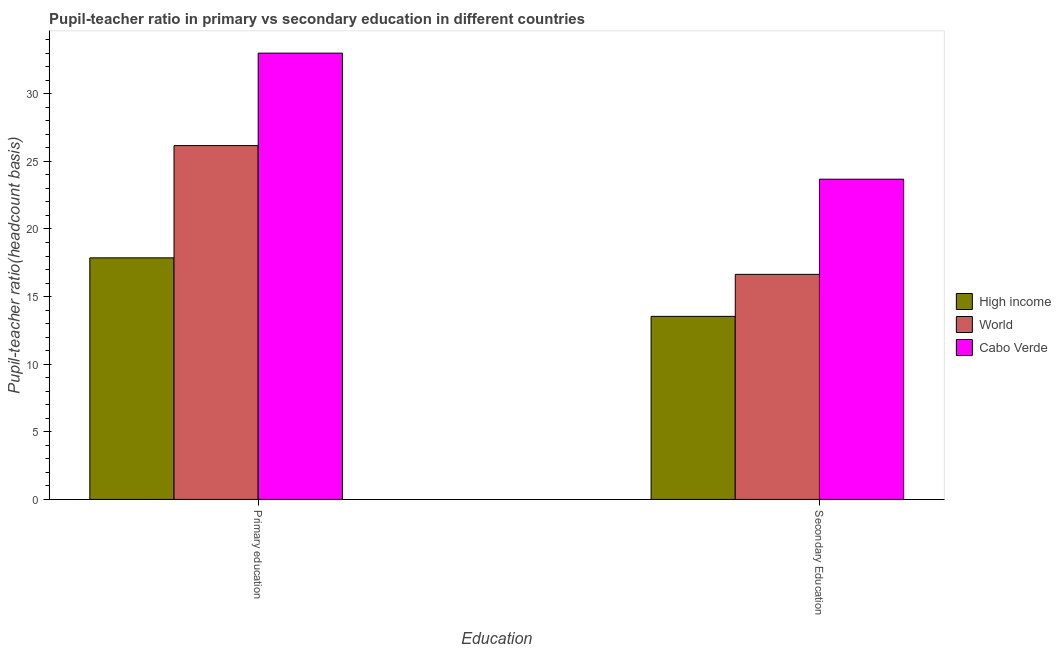How many different coloured bars are there?
Your response must be concise. 3. How many groups of bars are there?
Provide a succinct answer. 2. Are the number of bars per tick equal to the number of legend labels?
Keep it short and to the point. Yes. Are the number of bars on each tick of the X-axis equal?
Offer a very short reply. Yes. What is the label of the 1st group of bars from the left?
Keep it short and to the point. Primary education. What is the pupil-teacher ratio in primary education in High income?
Your answer should be compact. 17.86. Across all countries, what is the maximum pupil-teacher ratio in primary education?
Offer a very short reply. 33. Across all countries, what is the minimum pupil-teacher ratio in primary education?
Make the answer very short. 17.86. In which country was the pupil teacher ratio on secondary education maximum?
Your answer should be very brief. Cabo Verde. What is the total pupil-teacher ratio in primary education in the graph?
Make the answer very short. 77.03. What is the difference between the pupil-teacher ratio in primary education in Cabo Verde and that in High income?
Make the answer very short. 15.14. What is the difference between the pupil teacher ratio on secondary education in High income and the pupil-teacher ratio in primary education in Cabo Verde?
Give a very brief answer. -19.47. What is the average pupil-teacher ratio in primary education per country?
Provide a short and direct response. 25.68. What is the difference between the pupil-teacher ratio in primary education and pupil teacher ratio on secondary education in Cabo Verde?
Provide a succinct answer. 9.32. In how many countries, is the pupil teacher ratio on secondary education greater than 28 ?
Provide a short and direct response. 0. What is the ratio of the pupil teacher ratio on secondary education in World to that in Cabo Verde?
Offer a terse response. 0.7. What does the 3rd bar from the left in Primary education represents?
Offer a very short reply. Cabo Verde. What does the 3rd bar from the right in Secondary Education represents?
Your response must be concise. High income. How many bars are there?
Offer a terse response. 6. Are all the bars in the graph horizontal?
Offer a very short reply. No. How many countries are there in the graph?
Keep it short and to the point. 3. Are the values on the major ticks of Y-axis written in scientific E-notation?
Provide a succinct answer. No. Does the graph contain any zero values?
Offer a terse response. No. How are the legend labels stacked?
Keep it short and to the point. Vertical. What is the title of the graph?
Your answer should be compact. Pupil-teacher ratio in primary vs secondary education in different countries. What is the label or title of the X-axis?
Provide a succinct answer. Education. What is the label or title of the Y-axis?
Your response must be concise. Pupil-teacher ratio(headcount basis). What is the Pupil-teacher ratio(headcount basis) in High income in Primary education?
Your answer should be very brief. 17.86. What is the Pupil-teacher ratio(headcount basis) in World in Primary education?
Keep it short and to the point. 26.16. What is the Pupil-teacher ratio(headcount basis) of Cabo Verde in Primary education?
Your response must be concise. 33. What is the Pupil-teacher ratio(headcount basis) in High income in Secondary Education?
Your answer should be very brief. 13.54. What is the Pupil-teacher ratio(headcount basis) in World in Secondary Education?
Offer a terse response. 16.64. What is the Pupil-teacher ratio(headcount basis) of Cabo Verde in Secondary Education?
Your response must be concise. 23.68. Across all Education, what is the maximum Pupil-teacher ratio(headcount basis) of High income?
Your answer should be compact. 17.86. Across all Education, what is the maximum Pupil-teacher ratio(headcount basis) of World?
Ensure brevity in your answer.  26.16. Across all Education, what is the maximum Pupil-teacher ratio(headcount basis) of Cabo Verde?
Give a very brief answer. 33. Across all Education, what is the minimum Pupil-teacher ratio(headcount basis) of High income?
Offer a very short reply. 13.54. Across all Education, what is the minimum Pupil-teacher ratio(headcount basis) in World?
Your response must be concise. 16.64. Across all Education, what is the minimum Pupil-teacher ratio(headcount basis) in Cabo Verde?
Offer a very short reply. 23.68. What is the total Pupil-teacher ratio(headcount basis) in High income in the graph?
Give a very brief answer. 31.4. What is the total Pupil-teacher ratio(headcount basis) in World in the graph?
Offer a terse response. 42.81. What is the total Pupil-teacher ratio(headcount basis) of Cabo Verde in the graph?
Give a very brief answer. 56.68. What is the difference between the Pupil-teacher ratio(headcount basis) of High income in Primary education and that in Secondary Education?
Make the answer very short. 4.33. What is the difference between the Pupil-teacher ratio(headcount basis) of World in Primary education and that in Secondary Education?
Provide a succinct answer. 9.52. What is the difference between the Pupil-teacher ratio(headcount basis) of Cabo Verde in Primary education and that in Secondary Education?
Your answer should be very brief. 9.32. What is the difference between the Pupil-teacher ratio(headcount basis) in High income in Primary education and the Pupil-teacher ratio(headcount basis) in World in Secondary Education?
Give a very brief answer. 1.22. What is the difference between the Pupil-teacher ratio(headcount basis) in High income in Primary education and the Pupil-teacher ratio(headcount basis) in Cabo Verde in Secondary Education?
Ensure brevity in your answer.  -5.82. What is the difference between the Pupil-teacher ratio(headcount basis) of World in Primary education and the Pupil-teacher ratio(headcount basis) of Cabo Verde in Secondary Education?
Offer a terse response. 2.48. What is the average Pupil-teacher ratio(headcount basis) in High income per Education?
Make the answer very short. 15.7. What is the average Pupil-teacher ratio(headcount basis) in World per Education?
Make the answer very short. 21.4. What is the average Pupil-teacher ratio(headcount basis) of Cabo Verde per Education?
Your answer should be compact. 28.34. What is the difference between the Pupil-teacher ratio(headcount basis) of High income and Pupil-teacher ratio(headcount basis) of World in Primary education?
Keep it short and to the point. -8.3. What is the difference between the Pupil-teacher ratio(headcount basis) in High income and Pupil-teacher ratio(headcount basis) in Cabo Verde in Primary education?
Make the answer very short. -15.14. What is the difference between the Pupil-teacher ratio(headcount basis) of World and Pupil-teacher ratio(headcount basis) of Cabo Verde in Primary education?
Provide a short and direct response. -6.84. What is the difference between the Pupil-teacher ratio(headcount basis) in High income and Pupil-teacher ratio(headcount basis) in World in Secondary Education?
Make the answer very short. -3.11. What is the difference between the Pupil-teacher ratio(headcount basis) of High income and Pupil-teacher ratio(headcount basis) of Cabo Verde in Secondary Education?
Give a very brief answer. -10.14. What is the difference between the Pupil-teacher ratio(headcount basis) in World and Pupil-teacher ratio(headcount basis) in Cabo Verde in Secondary Education?
Your answer should be very brief. -7.04. What is the ratio of the Pupil-teacher ratio(headcount basis) of High income in Primary education to that in Secondary Education?
Offer a very short reply. 1.32. What is the ratio of the Pupil-teacher ratio(headcount basis) in World in Primary education to that in Secondary Education?
Provide a short and direct response. 1.57. What is the ratio of the Pupil-teacher ratio(headcount basis) of Cabo Verde in Primary education to that in Secondary Education?
Ensure brevity in your answer.  1.39. What is the difference between the highest and the second highest Pupil-teacher ratio(headcount basis) of High income?
Offer a terse response. 4.33. What is the difference between the highest and the second highest Pupil-teacher ratio(headcount basis) in World?
Keep it short and to the point. 9.52. What is the difference between the highest and the second highest Pupil-teacher ratio(headcount basis) of Cabo Verde?
Give a very brief answer. 9.32. What is the difference between the highest and the lowest Pupil-teacher ratio(headcount basis) in High income?
Provide a succinct answer. 4.33. What is the difference between the highest and the lowest Pupil-teacher ratio(headcount basis) in World?
Keep it short and to the point. 9.52. What is the difference between the highest and the lowest Pupil-teacher ratio(headcount basis) in Cabo Verde?
Your answer should be compact. 9.32. 